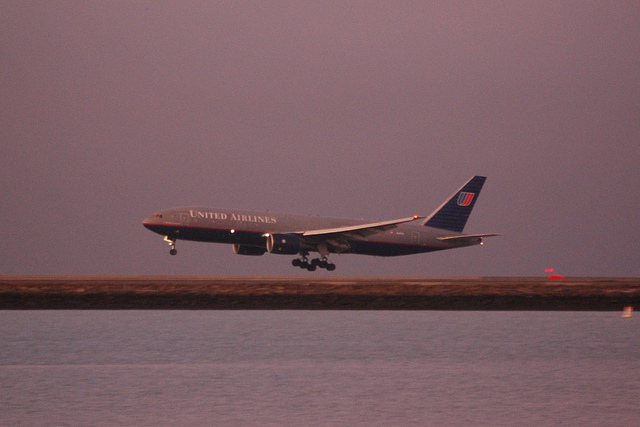<image>What's natural landmark is in the background? It is unknown which natural landmark is in the background. It could be an ocean, river, sandbar, desert, plains or beach. What's natural landmark is in the background? I don't know what natural landmark is in the background. It can be either ocean, river, sandbar, desert, plains, or beach. 